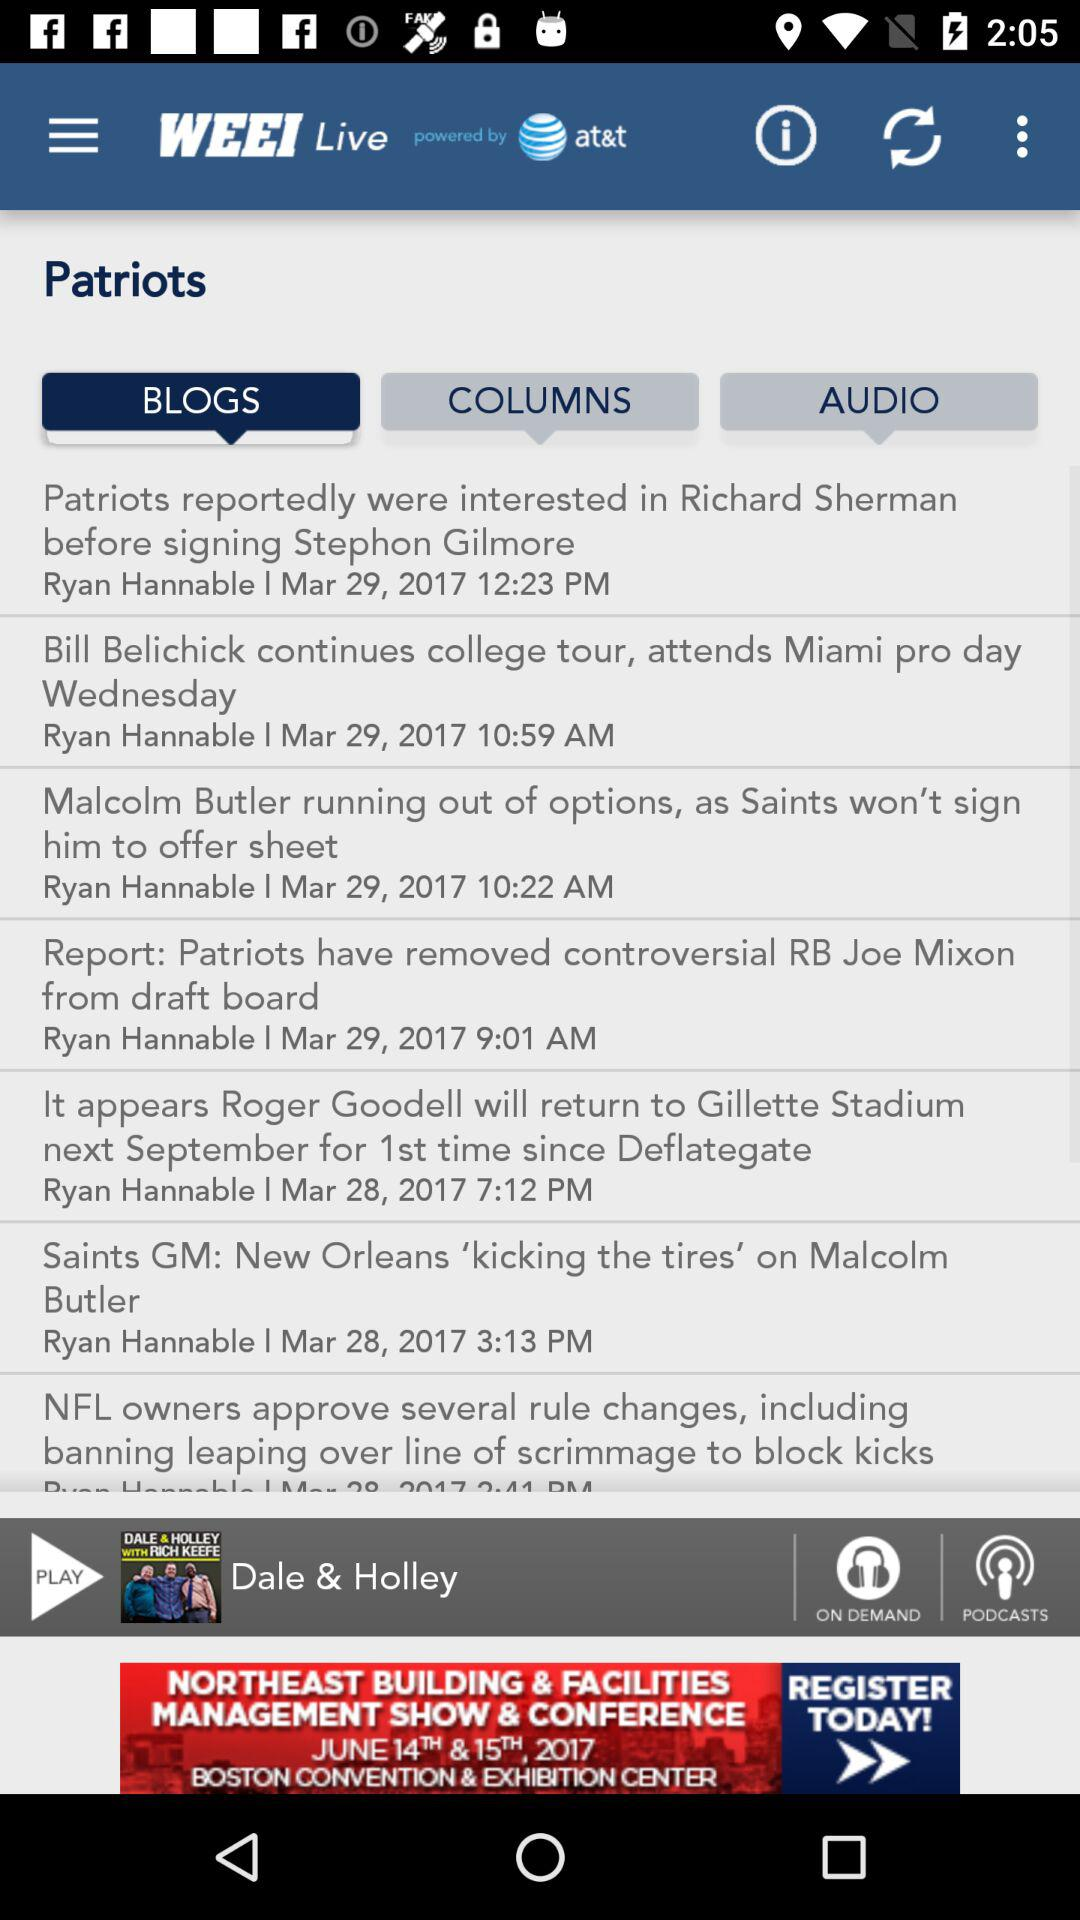What is the name of the blog which was posted on March 28, 2017? The names of the blogs are "It appears Roger Goodell will return to Gillette Stadium next September for 1st time since Deflategate" and "Saints GM: New Orleans 'kicking the tires' on Malcolm Butler". 